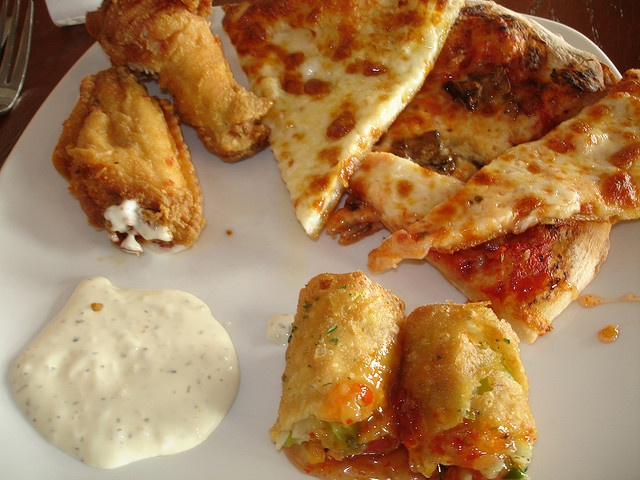Describe the objects in this image and their specific colors. I can see pizza in black, brown, maroon, and tan tones and fork in black, maroon, and gray tones in this image. 